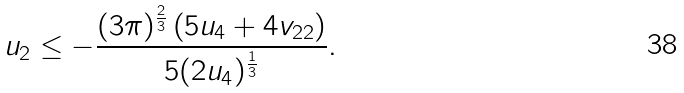Convert formula to latex. <formula><loc_0><loc_0><loc_500><loc_500>u _ { 2 } \leq - \frac { ( 3 \pi ) ^ { \frac { 2 } { 3 } } \left ( 5 u _ { 4 } + 4 v _ { 2 2 } \right ) } { 5 ( 2 u _ { 4 } ) ^ { \frac { 1 } { 3 } } } .</formula> 